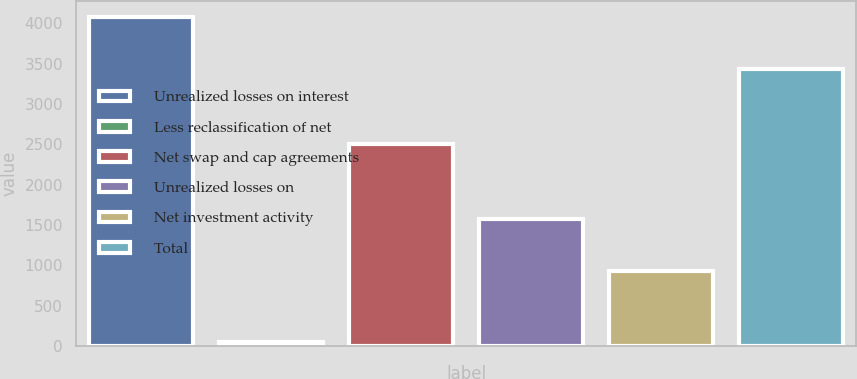Convert chart to OTSL. <chart><loc_0><loc_0><loc_500><loc_500><bar_chart><fcel>Unrealized losses on interest<fcel>Less reclassification of net<fcel>Net swap and cap agreements<fcel>Unrealized losses on<fcel>Net investment activity<fcel>Total<nl><fcel>4073<fcel>48<fcel>2498<fcel>1575<fcel>935<fcel>3433<nl></chart> 